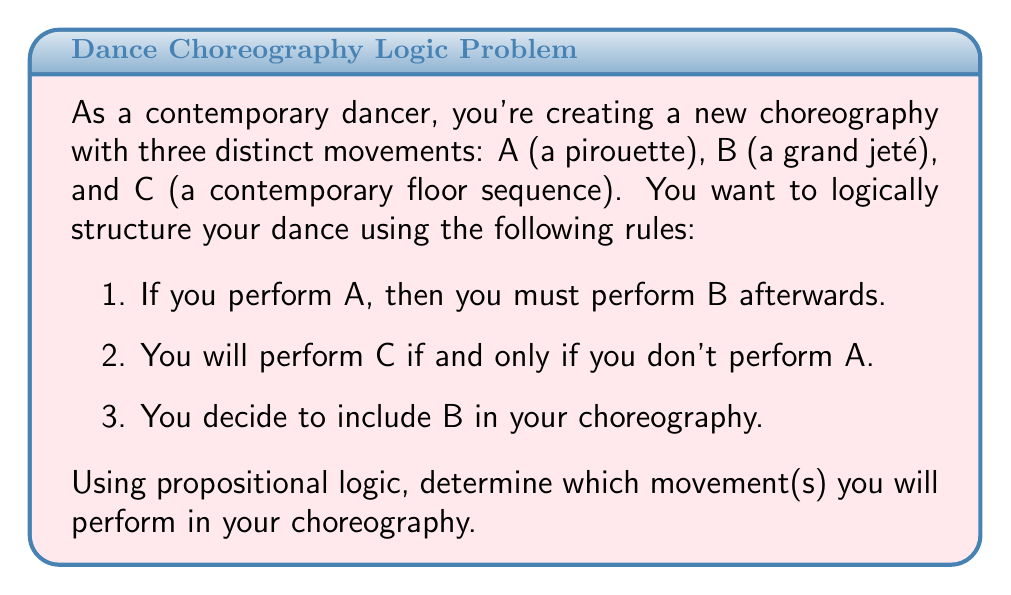Help me with this question. Let's approach this step-by-step using propositional logic:

1) First, let's define our propositions:
   $A$: Perform a pirouette
   $B$: Perform a grand jeté
   $C$: Perform a contemporary floor sequence

2) Now, let's translate the given rules into logical statements:
   Rule 1: $A \implies B$ (If A, then B)
   Rule 2: $C \iff \neg A$ (C if and only if not A)
   Rule 3: $B$ (B is true)

3) From Rule 3, we know that $B$ is true. This is our starting point.

4) Now, let's consider Rule 1: $A \implies B$
   We know $B$ is true, but this doesn't necessarily mean $A$ is true. 
   (The implication only works one way: A implies B, but B doesn't always imply A)

5) Let's consider both possibilities for $A$:

   Case 1: If $A$ is true
   - $B$ would be true (which matches our given information)
   - From Rule 2 ($C \iff \neg A$), we know $C$ would be false

   Case 2: If $A$ is false
   - $B$ is still true (which matches our given information)
   - From Rule 2, we know $C$ would be true

6) Both cases satisfy Rule 1 and Rule 3. However, we need to determine which case is actually true.

7) The key is in Rule 1: $A \implies B$
   We know $B$ is true, and if $A$ were false, this implication would still hold.
   However, if $A$ were true, it would force $B$ to be true.

8) In propositional logic, we prefer the simplest explanation that satisfies all conditions.
   Since $B$ is already true (given in Rule 3), we don't need $A$ to be true to explain it.

9) Therefore, we conclude that $A$ is false and $C$ is true (from Rule 2).

Thus, the logical structure of your choreography will include movements B and C, but not A.
Answer: You will perform B (grand jeté) and C (contemporary floor sequence) in your choreography. 